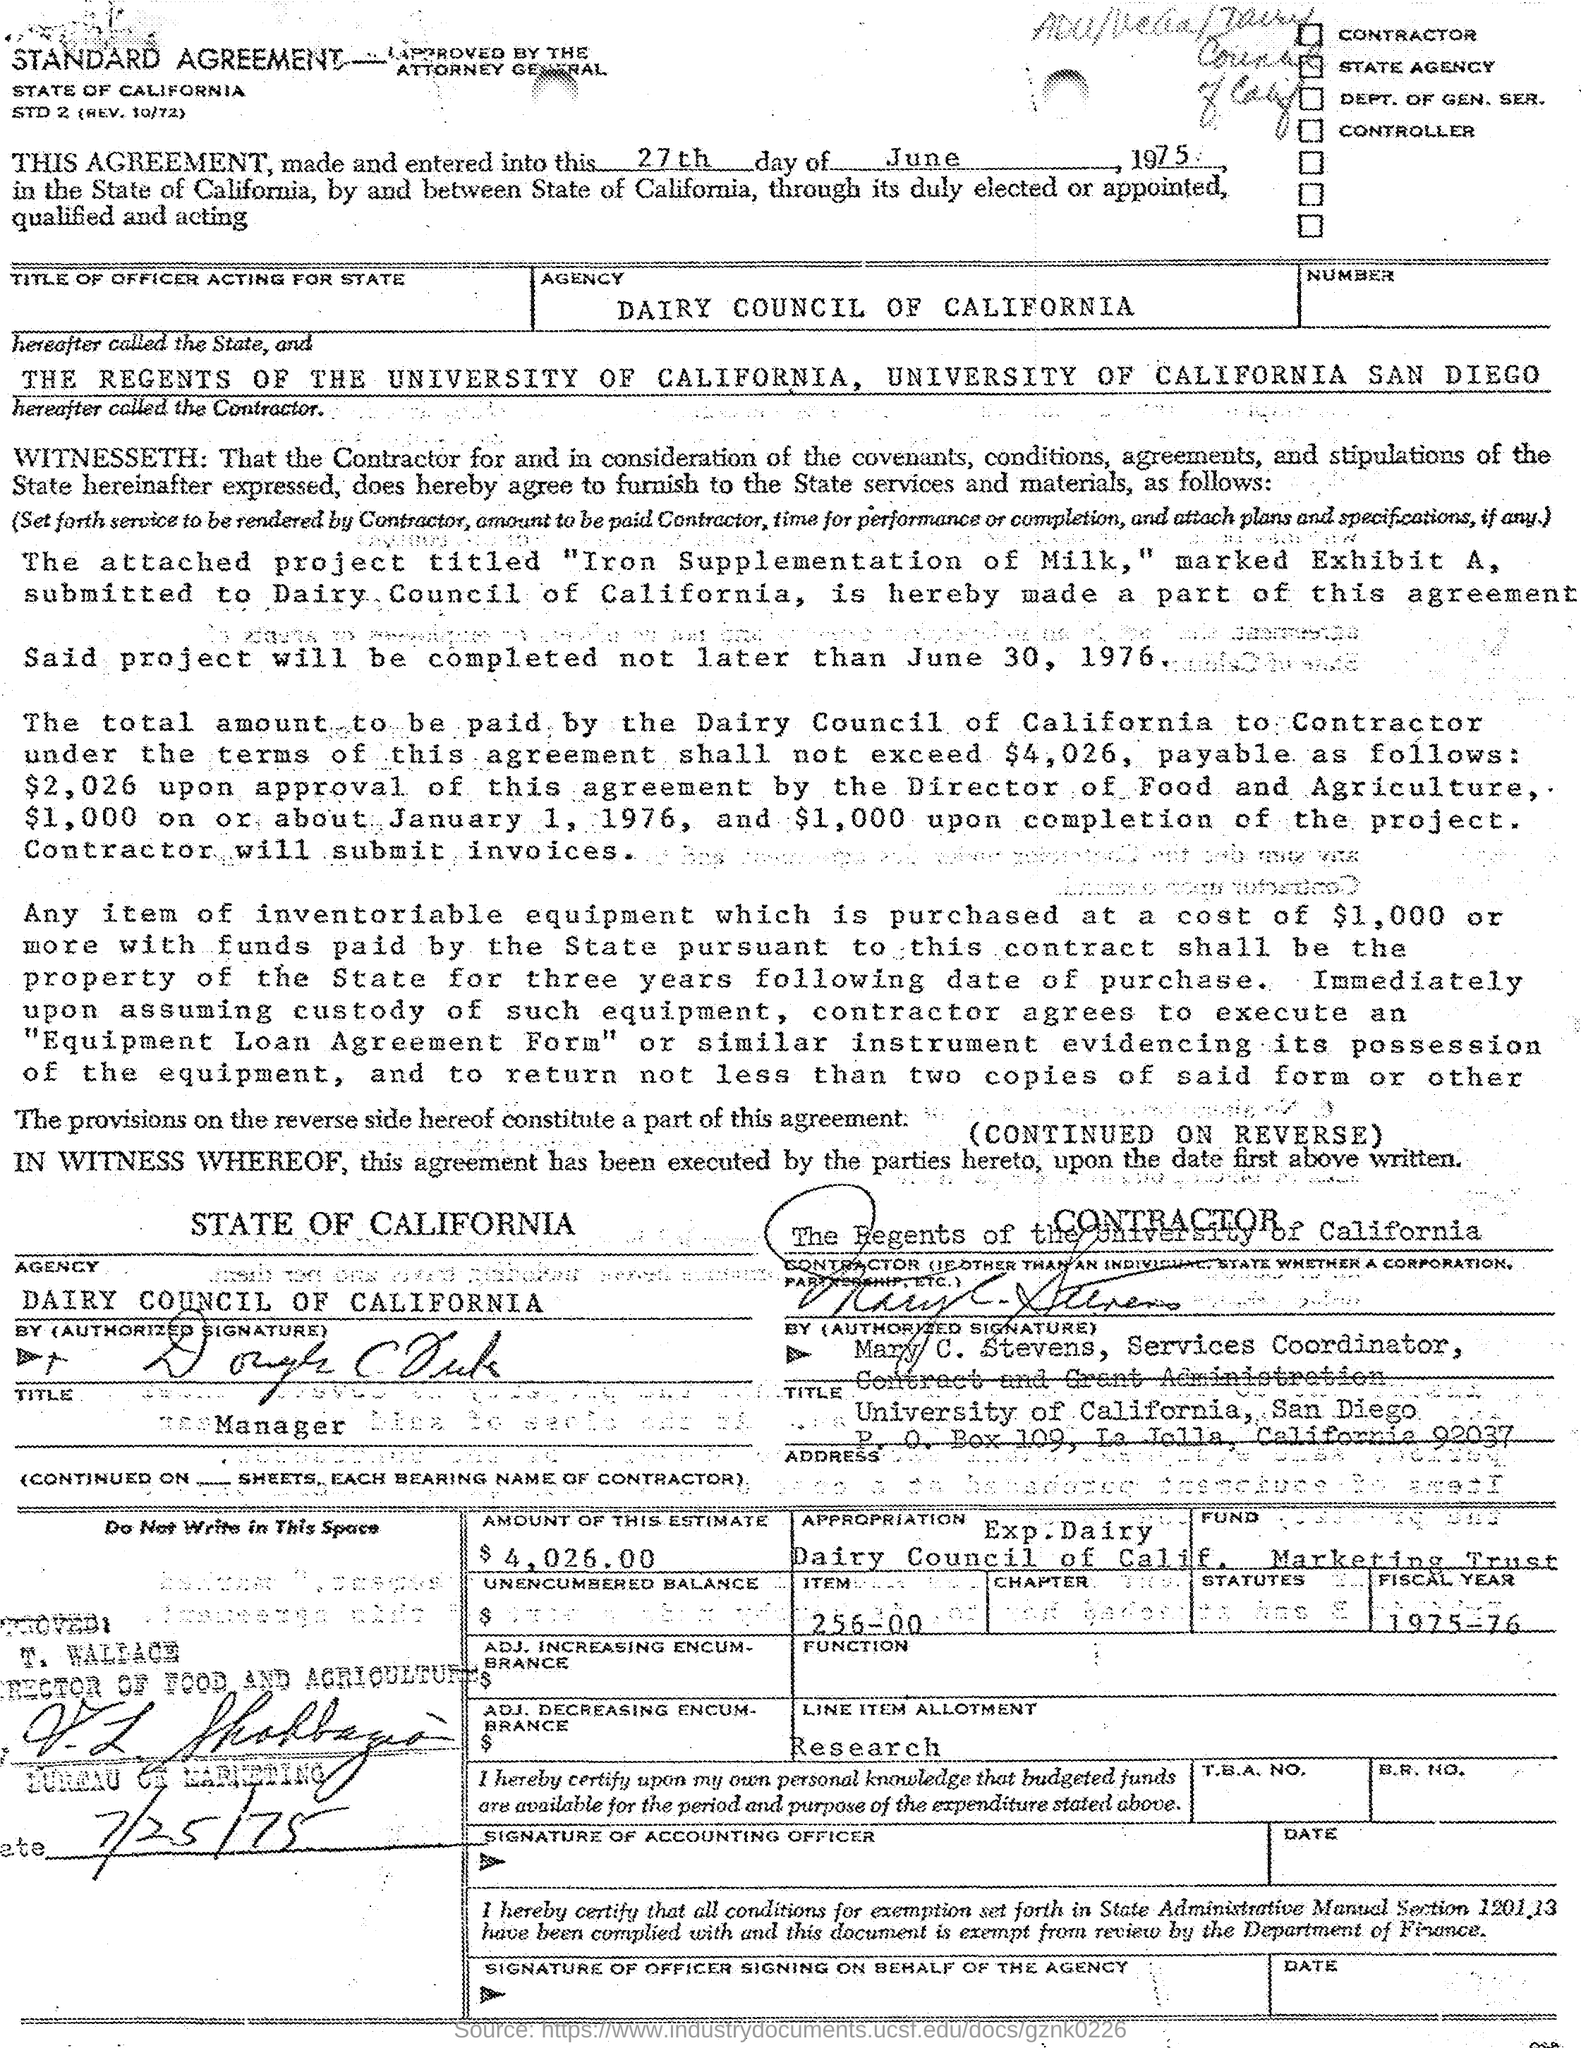What is the name of agency
Your answer should be compact. Dairy council of california. The project will be completed not later than which date ?
Make the answer very short. June 30, 1976. What is the fiscal year mentioned ?
Your response must be concise. 1975-76. Who is the director of food and agriculture ?
Your answer should be compact. T. WALLACE. Who is the service coordinator , contract and grand administration
Offer a very short reply. Mary c. stevens. 